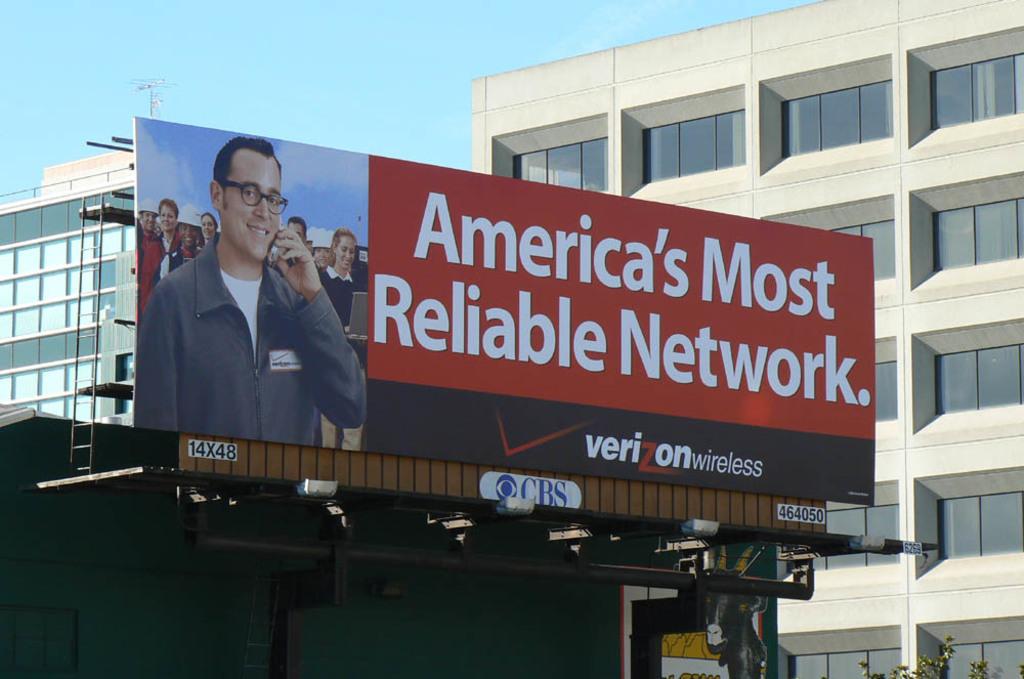What television company is listed below the billboard?
Your response must be concise. Cbs. 